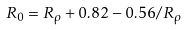Convert formula to latex. <formula><loc_0><loc_0><loc_500><loc_500>R _ { 0 } = R _ { \rho } + 0 . 8 2 - 0 . 5 6 / R _ { \rho }</formula> 